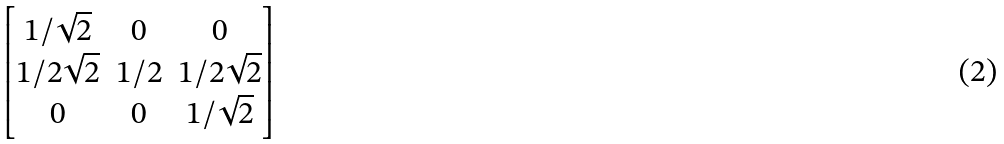<formula> <loc_0><loc_0><loc_500><loc_500>\begin{bmatrix} 1 / \sqrt { 2 } & 0 & 0 \\ 1 / 2 \sqrt { 2 } & 1 / 2 & 1 / 2 \sqrt { 2 } \\ 0 & 0 & 1 / \sqrt { 2 } \end{bmatrix}</formula> 